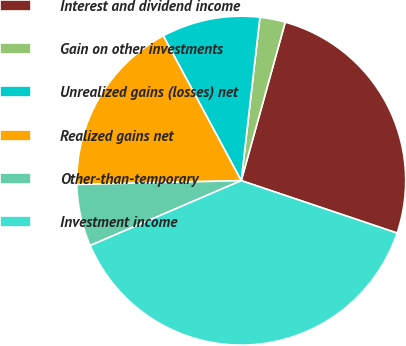<chart> <loc_0><loc_0><loc_500><loc_500><pie_chart><fcel>Interest and dividend income<fcel>Gain on other investments<fcel>Unrealized gains (losses) net<fcel>Realized gains net<fcel>Other-than-temporary<fcel>Investment income<nl><fcel>25.85%<fcel>2.5%<fcel>9.67%<fcel>17.51%<fcel>6.09%<fcel>38.37%<nl></chart> 